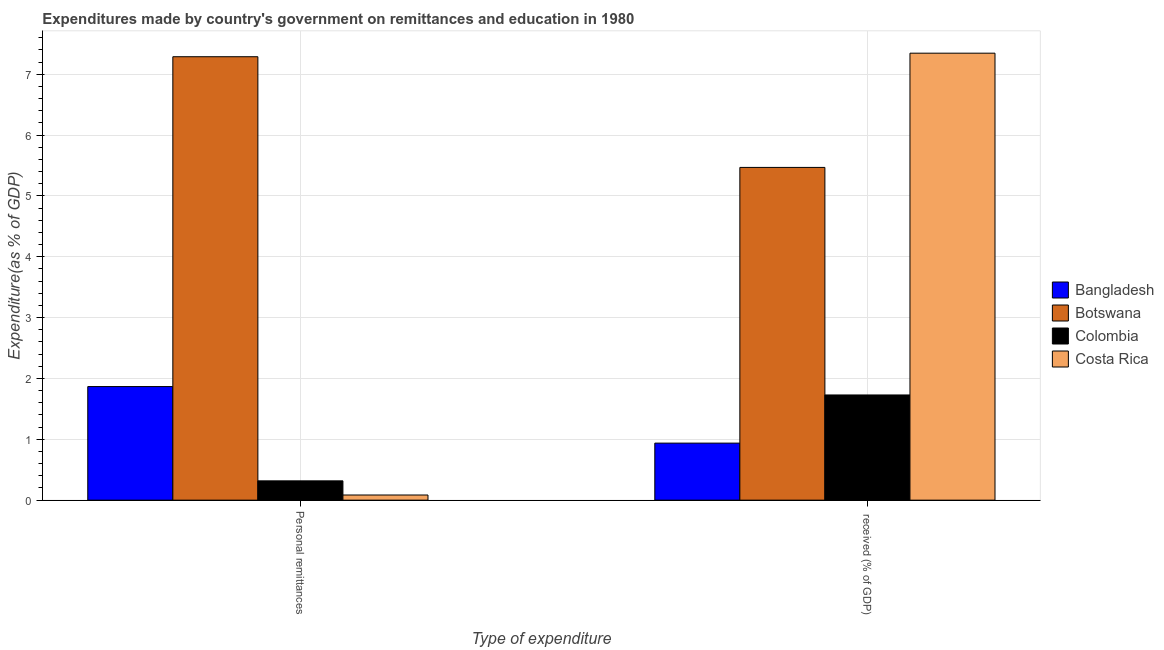Are the number of bars per tick equal to the number of legend labels?
Keep it short and to the point. Yes. How many bars are there on the 1st tick from the right?
Your answer should be compact. 4. What is the label of the 2nd group of bars from the left?
Ensure brevity in your answer.   received (% of GDP). What is the expenditure in education in Bangladesh?
Provide a short and direct response. 0.94. Across all countries, what is the maximum expenditure in education?
Your answer should be very brief. 7.35. Across all countries, what is the minimum expenditure in personal remittances?
Offer a terse response. 0.08. In which country was the expenditure in education maximum?
Ensure brevity in your answer.  Costa Rica. What is the total expenditure in personal remittances in the graph?
Offer a very short reply. 9.56. What is the difference between the expenditure in personal remittances in Colombia and that in Costa Rica?
Offer a terse response. 0.23. What is the difference between the expenditure in education in Colombia and the expenditure in personal remittances in Botswana?
Provide a short and direct response. -5.56. What is the average expenditure in education per country?
Keep it short and to the point. 3.87. What is the difference between the expenditure in personal remittances and expenditure in education in Bangladesh?
Ensure brevity in your answer.  0.93. In how many countries, is the expenditure in personal remittances greater than 4.8 %?
Keep it short and to the point. 1. What is the ratio of the expenditure in education in Botswana to that in Bangladesh?
Ensure brevity in your answer.  5.83. Is the expenditure in education in Bangladesh less than that in Botswana?
Your answer should be compact. Yes. How many bars are there?
Offer a terse response. 8. Are the values on the major ticks of Y-axis written in scientific E-notation?
Your response must be concise. No. Does the graph contain any zero values?
Make the answer very short. No. Does the graph contain grids?
Your response must be concise. Yes. How many legend labels are there?
Your answer should be compact. 4. How are the legend labels stacked?
Keep it short and to the point. Vertical. What is the title of the graph?
Your answer should be compact. Expenditures made by country's government on remittances and education in 1980. Does "Suriname" appear as one of the legend labels in the graph?
Your answer should be very brief. No. What is the label or title of the X-axis?
Offer a terse response. Type of expenditure. What is the label or title of the Y-axis?
Your answer should be very brief. Expenditure(as % of GDP). What is the Expenditure(as % of GDP) in Bangladesh in Personal remittances?
Give a very brief answer. 1.87. What is the Expenditure(as % of GDP) in Botswana in Personal remittances?
Keep it short and to the point. 7.29. What is the Expenditure(as % of GDP) in Colombia in Personal remittances?
Ensure brevity in your answer.  0.32. What is the Expenditure(as % of GDP) in Costa Rica in Personal remittances?
Give a very brief answer. 0.08. What is the Expenditure(as % of GDP) of Bangladesh in  received (% of GDP)?
Your answer should be compact. 0.94. What is the Expenditure(as % of GDP) of Botswana in  received (% of GDP)?
Offer a terse response. 5.47. What is the Expenditure(as % of GDP) of Colombia in  received (% of GDP)?
Your answer should be very brief. 1.73. What is the Expenditure(as % of GDP) of Costa Rica in  received (% of GDP)?
Make the answer very short. 7.35. Across all Type of expenditure, what is the maximum Expenditure(as % of GDP) of Bangladesh?
Offer a very short reply. 1.87. Across all Type of expenditure, what is the maximum Expenditure(as % of GDP) of Botswana?
Your response must be concise. 7.29. Across all Type of expenditure, what is the maximum Expenditure(as % of GDP) in Colombia?
Give a very brief answer. 1.73. Across all Type of expenditure, what is the maximum Expenditure(as % of GDP) in Costa Rica?
Keep it short and to the point. 7.35. Across all Type of expenditure, what is the minimum Expenditure(as % of GDP) in Bangladesh?
Your answer should be compact. 0.94. Across all Type of expenditure, what is the minimum Expenditure(as % of GDP) in Botswana?
Keep it short and to the point. 5.47. Across all Type of expenditure, what is the minimum Expenditure(as % of GDP) of Colombia?
Your response must be concise. 0.32. Across all Type of expenditure, what is the minimum Expenditure(as % of GDP) of Costa Rica?
Provide a succinct answer. 0.08. What is the total Expenditure(as % of GDP) in Bangladesh in the graph?
Provide a short and direct response. 2.8. What is the total Expenditure(as % of GDP) in Botswana in the graph?
Your answer should be very brief. 12.76. What is the total Expenditure(as % of GDP) of Colombia in the graph?
Provide a short and direct response. 2.05. What is the total Expenditure(as % of GDP) of Costa Rica in the graph?
Provide a succinct answer. 7.43. What is the difference between the Expenditure(as % of GDP) in Bangladesh in Personal remittances and that in  received (% of GDP)?
Keep it short and to the point. 0.93. What is the difference between the Expenditure(as % of GDP) of Botswana in Personal remittances and that in  received (% of GDP)?
Your answer should be very brief. 1.82. What is the difference between the Expenditure(as % of GDP) in Colombia in Personal remittances and that in  received (% of GDP)?
Offer a terse response. -1.41. What is the difference between the Expenditure(as % of GDP) in Costa Rica in Personal remittances and that in  received (% of GDP)?
Provide a short and direct response. -7.26. What is the difference between the Expenditure(as % of GDP) in Bangladesh in Personal remittances and the Expenditure(as % of GDP) in Botswana in  received (% of GDP)?
Your answer should be very brief. -3.6. What is the difference between the Expenditure(as % of GDP) of Bangladesh in Personal remittances and the Expenditure(as % of GDP) of Colombia in  received (% of GDP)?
Your response must be concise. 0.14. What is the difference between the Expenditure(as % of GDP) of Bangladesh in Personal remittances and the Expenditure(as % of GDP) of Costa Rica in  received (% of GDP)?
Provide a succinct answer. -5.48. What is the difference between the Expenditure(as % of GDP) of Botswana in Personal remittances and the Expenditure(as % of GDP) of Colombia in  received (% of GDP)?
Ensure brevity in your answer.  5.56. What is the difference between the Expenditure(as % of GDP) of Botswana in Personal remittances and the Expenditure(as % of GDP) of Costa Rica in  received (% of GDP)?
Your response must be concise. -0.06. What is the difference between the Expenditure(as % of GDP) in Colombia in Personal remittances and the Expenditure(as % of GDP) in Costa Rica in  received (% of GDP)?
Give a very brief answer. -7.03. What is the average Expenditure(as % of GDP) in Bangladesh per Type of expenditure?
Your answer should be compact. 1.4. What is the average Expenditure(as % of GDP) in Botswana per Type of expenditure?
Keep it short and to the point. 6.38. What is the average Expenditure(as % of GDP) in Colombia per Type of expenditure?
Provide a short and direct response. 1.02. What is the average Expenditure(as % of GDP) of Costa Rica per Type of expenditure?
Provide a short and direct response. 3.72. What is the difference between the Expenditure(as % of GDP) in Bangladesh and Expenditure(as % of GDP) in Botswana in Personal remittances?
Keep it short and to the point. -5.42. What is the difference between the Expenditure(as % of GDP) in Bangladesh and Expenditure(as % of GDP) in Colombia in Personal remittances?
Keep it short and to the point. 1.55. What is the difference between the Expenditure(as % of GDP) of Bangladesh and Expenditure(as % of GDP) of Costa Rica in Personal remittances?
Give a very brief answer. 1.78. What is the difference between the Expenditure(as % of GDP) of Botswana and Expenditure(as % of GDP) of Colombia in Personal remittances?
Provide a succinct answer. 6.97. What is the difference between the Expenditure(as % of GDP) of Botswana and Expenditure(as % of GDP) of Costa Rica in Personal remittances?
Ensure brevity in your answer.  7.2. What is the difference between the Expenditure(as % of GDP) in Colombia and Expenditure(as % of GDP) in Costa Rica in Personal remittances?
Make the answer very short. 0.23. What is the difference between the Expenditure(as % of GDP) in Bangladesh and Expenditure(as % of GDP) in Botswana in  received (% of GDP)?
Offer a terse response. -4.53. What is the difference between the Expenditure(as % of GDP) in Bangladesh and Expenditure(as % of GDP) in Colombia in  received (% of GDP)?
Keep it short and to the point. -0.79. What is the difference between the Expenditure(as % of GDP) in Bangladesh and Expenditure(as % of GDP) in Costa Rica in  received (% of GDP)?
Ensure brevity in your answer.  -6.41. What is the difference between the Expenditure(as % of GDP) in Botswana and Expenditure(as % of GDP) in Colombia in  received (% of GDP)?
Provide a short and direct response. 3.74. What is the difference between the Expenditure(as % of GDP) of Botswana and Expenditure(as % of GDP) of Costa Rica in  received (% of GDP)?
Ensure brevity in your answer.  -1.88. What is the difference between the Expenditure(as % of GDP) of Colombia and Expenditure(as % of GDP) of Costa Rica in  received (% of GDP)?
Your answer should be compact. -5.62. What is the ratio of the Expenditure(as % of GDP) in Bangladesh in Personal remittances to that in  received (% of GDP)?
Your answer should be very brief. 1.99. What is the ratio of the Expenditure(as % of GDP) of Botswana in Personal remittances to that in  received (% of GDP)?
Keep it short and to the point. 1.33. What is the ratio of the Expenditure(as % of GDP) in Colombia in Personal remittances to that in  received (% of GDP)?
Offer a terse response. 0.18. What is the ratio of the Expenditure(as % of GDP) in Costa Rica in Personal remittances to that in  received (% of GDP)?
Make the answer very short. 0.01. What is the difference between the highest and the second highest Expenditure(as % of GDP) in Bangladesh?
Offer a terse response. 0.93. What is the difference between the highest and the second highest Expenditure(as % of GDP) of Botswana?
Give a very brief answer. 1.82. What is the difference between the highest and the second highest Expenditure(as % of GDP) in Colombia?
Your response must be concise. 1.41. What is the difference between the highest and the second highest Expenditure(as % of GDP) in Costa Rica?
Give a very brief answer. 7.26. What is the difference between the highest and the lowest Expenditure(as % of GDP) in Bangladesh?
Your answer should be compact. 0.93. What is the difference between the highest and the lowest Expenditure(as % of GDP) in Botswana?
Your answer should be compact. 1.82. What is the difference between the highest and the lowest Expenditure(as % of GDP) of Colombia?
Give a very brief answer. 1.41. What is the difference between the highest and the lowest Expenditure(as % of GDP) in Costa Rica?
Your answer should be very brief. 7.26. 